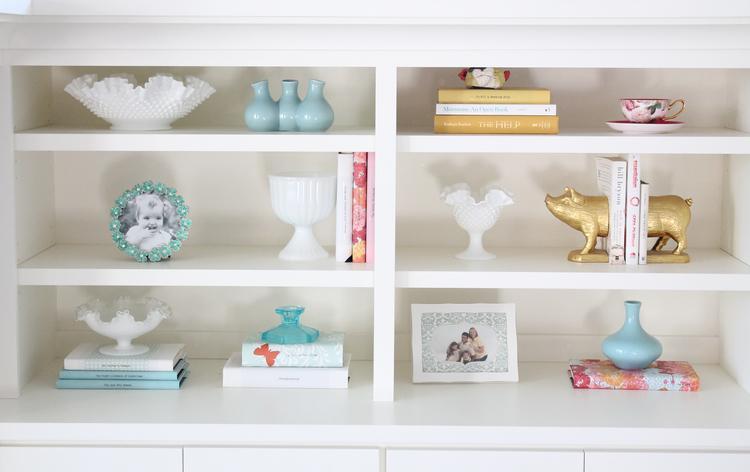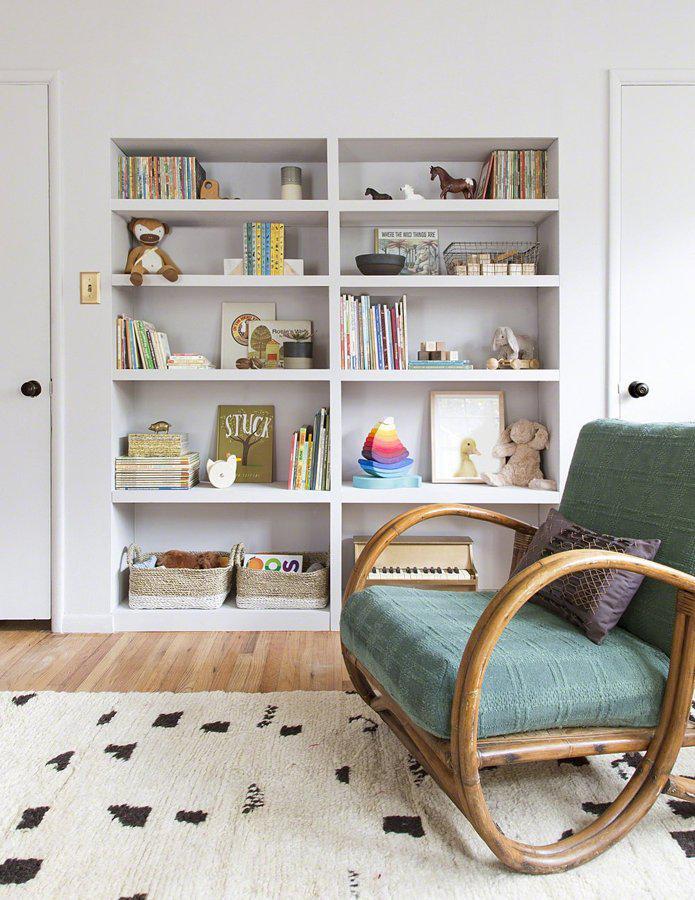The first image is the image on the left, the second image is the image on the right. For the images displayed, is the sentence "In one image, a free-standing white shelf is in front of a wall." factually correct? Answer yes or no. No. The first image is the image on the left, the second image is the image on the right. For the images displayed, is the sentence "A room image features seating furniture on the right and a bookcase with at least 8 shelves." factually correct? Answer yes or no. Yes. 